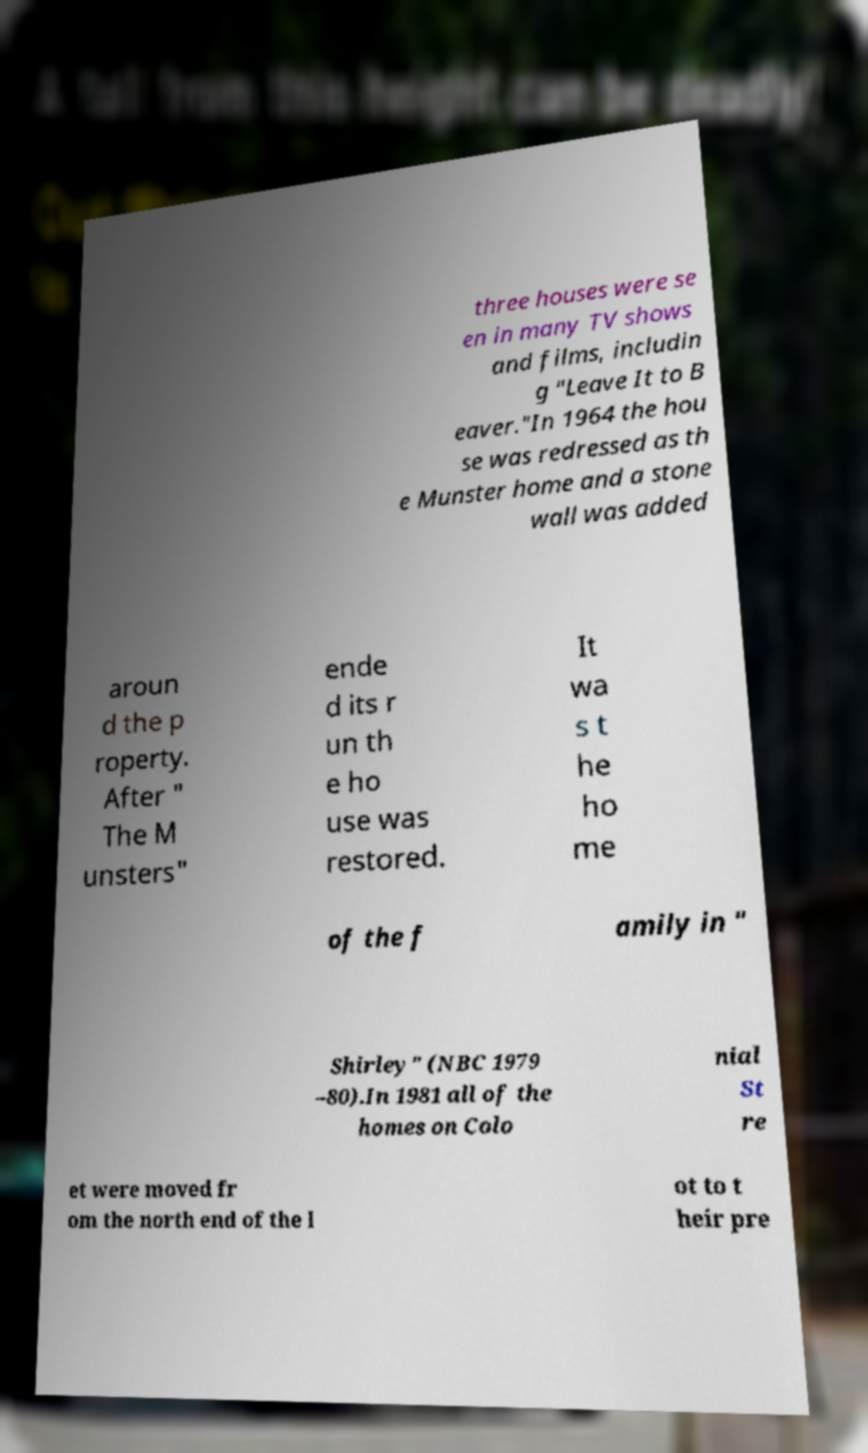For documentation purposes, I need the text within this image transcribed. Could you provide that? three houses were se en in many TV shows and films, includin g "Leave It to B eaver."In 1964 the hou se was redressed as th e Munster home and a stone wall was added aroun d the p roperty. After " The M unsters" ende d its r un th e ho use was restored. It wa s t he ho me of the f amily in " Shirley" (NBC 1979 –80).In 1981 all of the homes on Colo nial St re et were moved fr om the north end of the l ot to t heir pre 